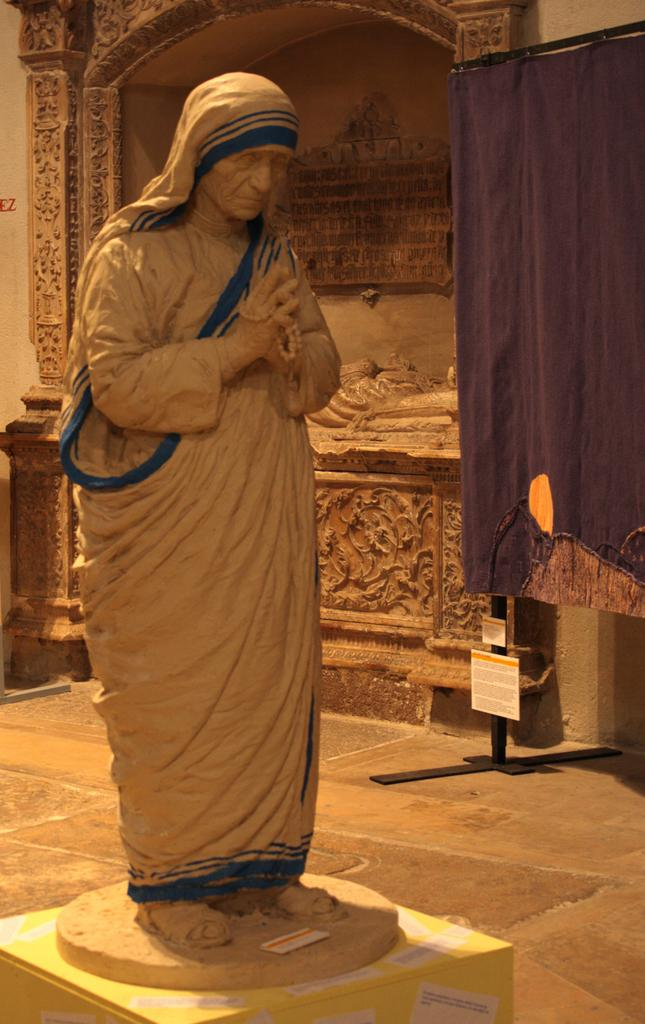What is the main subject of the image? There is a sculpture of Mother Teresa in the image. What can be seen behind the sculpture? There is another construction behind the sculpture. What color is the cloth on the right side of the image? There is a blue cloth on the right side of the image. What is the name of the person tasting the sculpture in the image? There is no person tasting the sculpture in the image; it is a sculpture made of a material that cannot be tasted. 